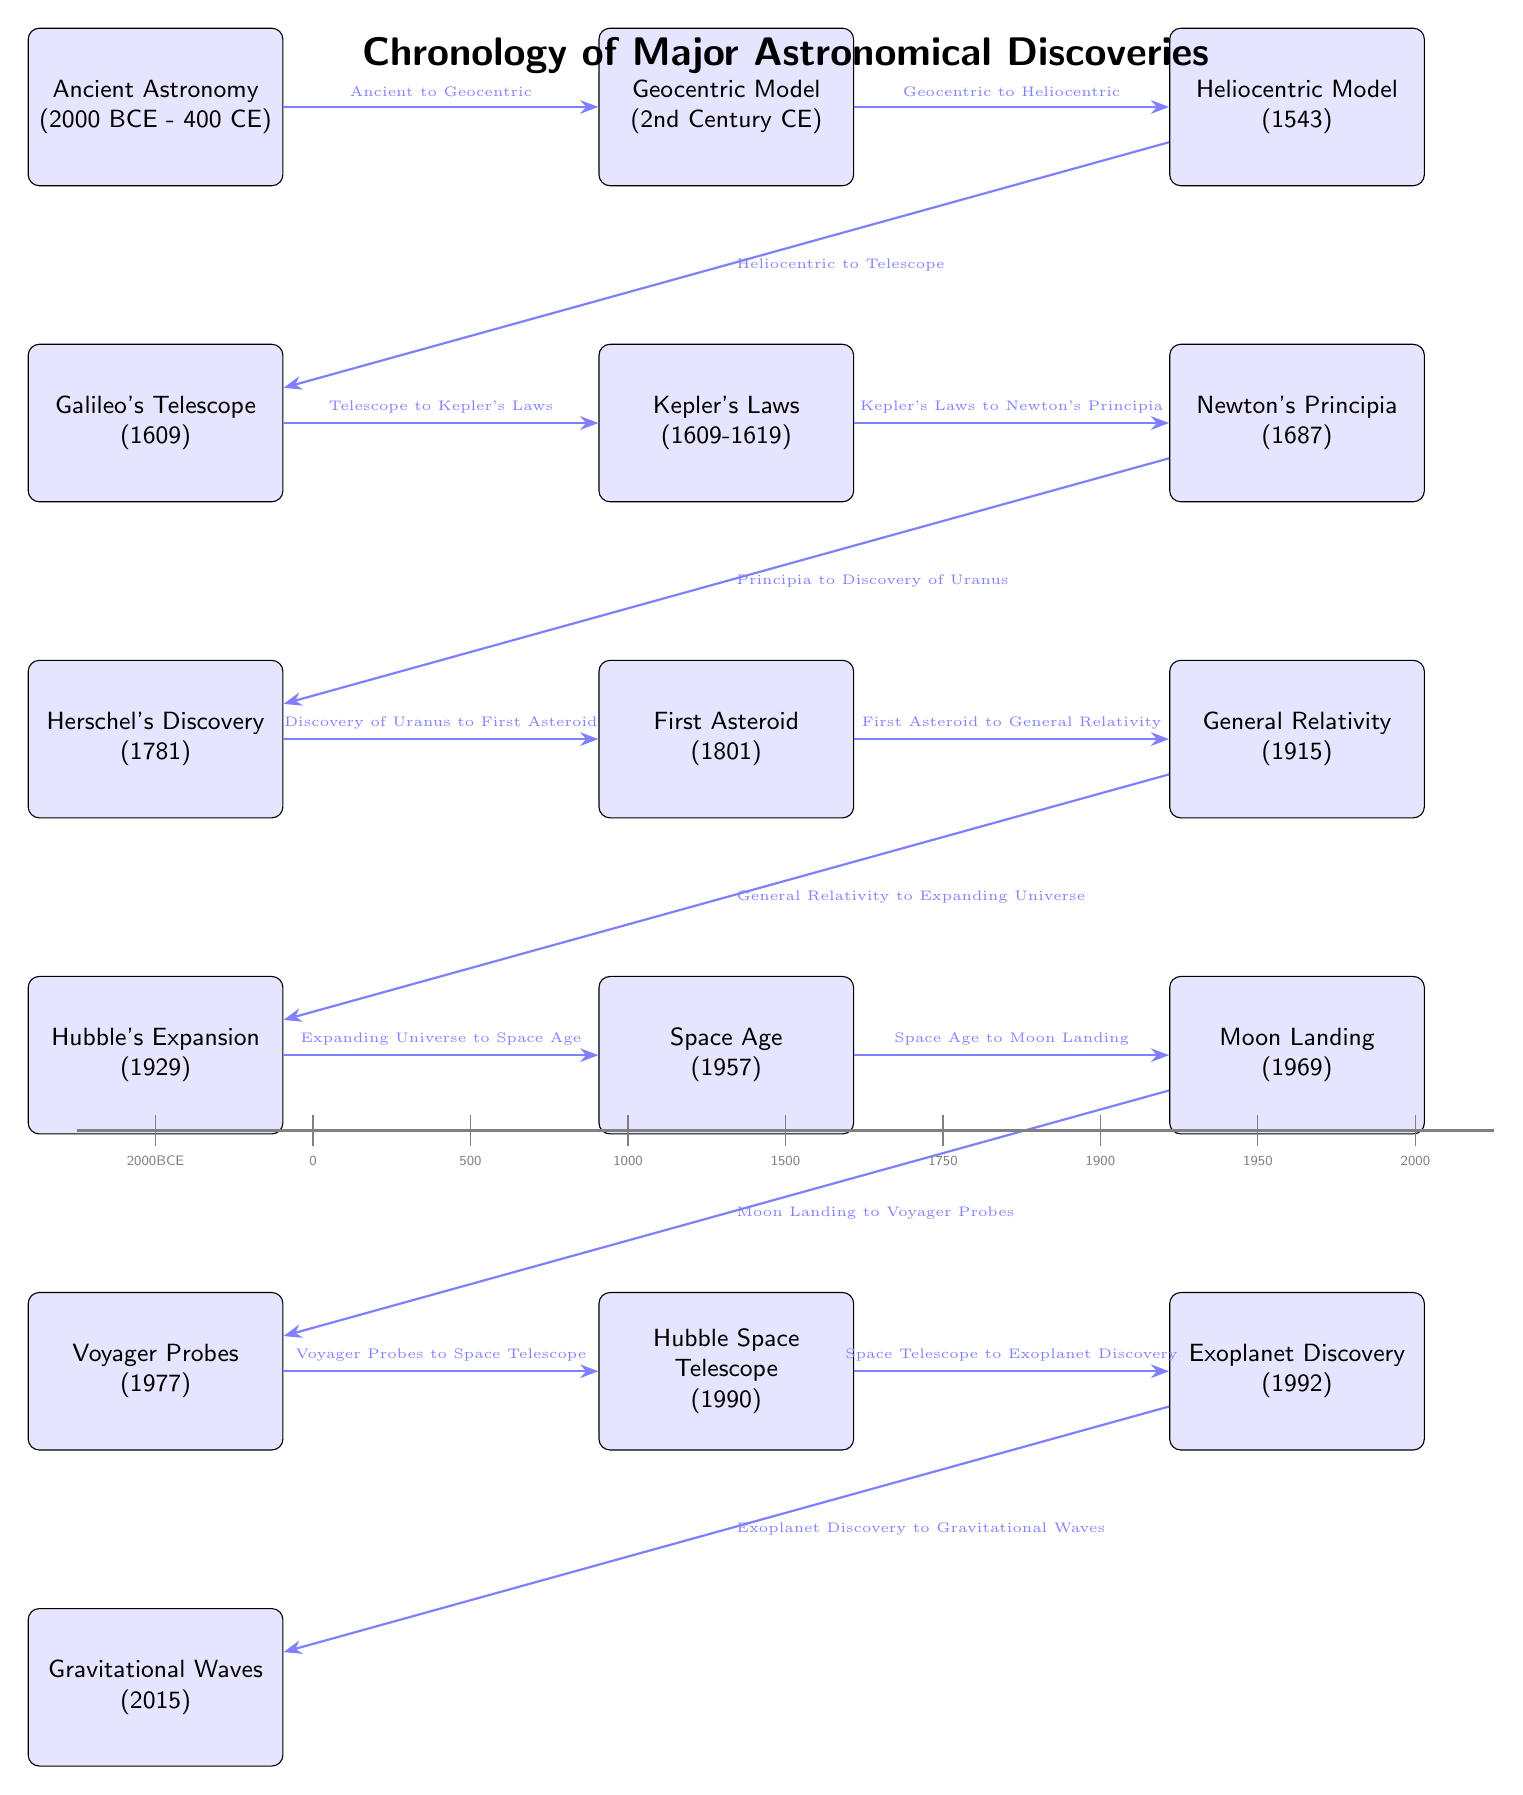What is the time period of Ancient Astronomy? The diagram indicates that Ancient Astronomy spans from 2000 BCE to 400 CE. This information is found in the first event node on the timeline.
Answer: 2000 BCE - 400 CE What discovery is associated with the year 1543? Looking at the third event node, we see that it represents the Heliocentric Model, which is noted to have been proposed in the year 1543.
Answer: Heliocentric Model Which event directly follows Galileo's Telescope? According to the arrows in the diagram, the event that follows Galileo's Telescope is Kepler's Laws, situated right next to it and connected by an arrow.
Answer: Kepler's Laws How many major events are plotted on the diagram? By counting the event nodes in the timeline, there are 16 major events illustrated, each corresponding to a significant astronomical discovery or advancement.
Answer: 16 What relationship does General Relativity have with the Expanding Universe? The diagram shows an arrow pointing from General Relativity to Expanding Universe, indicating a direct relationship where General Relativity is part of the theoretical framework for understanding the expanding universe.
Answer: General Relativity to Expanding Universe Which discovery was made first: Hubble's Expansion or Voyager Probes? Referring to the vertical position of these events in the diagram, Hubble's Expansion is above Voyager Probes, indicating that Hubble's Expansion occurred first in the timeline of advancements.
Answer: Hubble's Expansion What technology was introduced in 1957? The diagram specifies that the Space Age began in 1957, which is marked as a significant technological milestone in astronomy.
Answer: Space Age How does the timeline indicate advancements from the Telescope to Kepler's Laws? There is an arrow drawn from the Telescope event to Kepler's Laws event, suggesting that the development of the telescope technology facilitated the establishment of Kepler's Laws of planetary motion.
Answer: Telescope to Kepler's Laws What is the last discovery mentioned in the diagram? The final event node at the bottom of the timeline indicates the discovery of Gravitational Waves in the year 2015, marking it as the latest advancement.
Answer: Gravitational Waves 